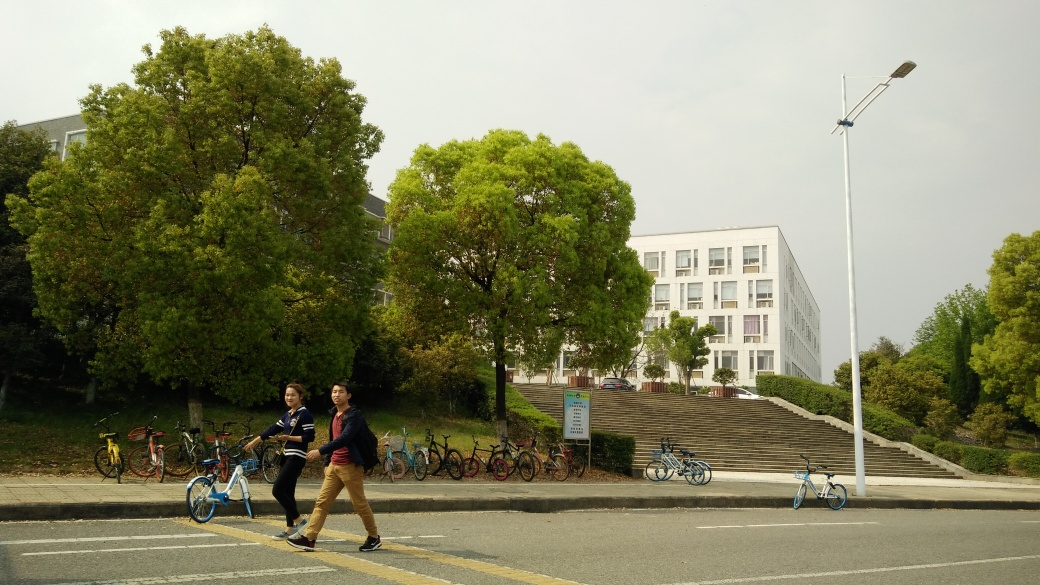What time of day does this image appear to have been taken? The image seems to have been taken during daylight hours, possibly in the morning or afternoon, as evidenced by the soft ambient lighting and the lack of strong shadows. 